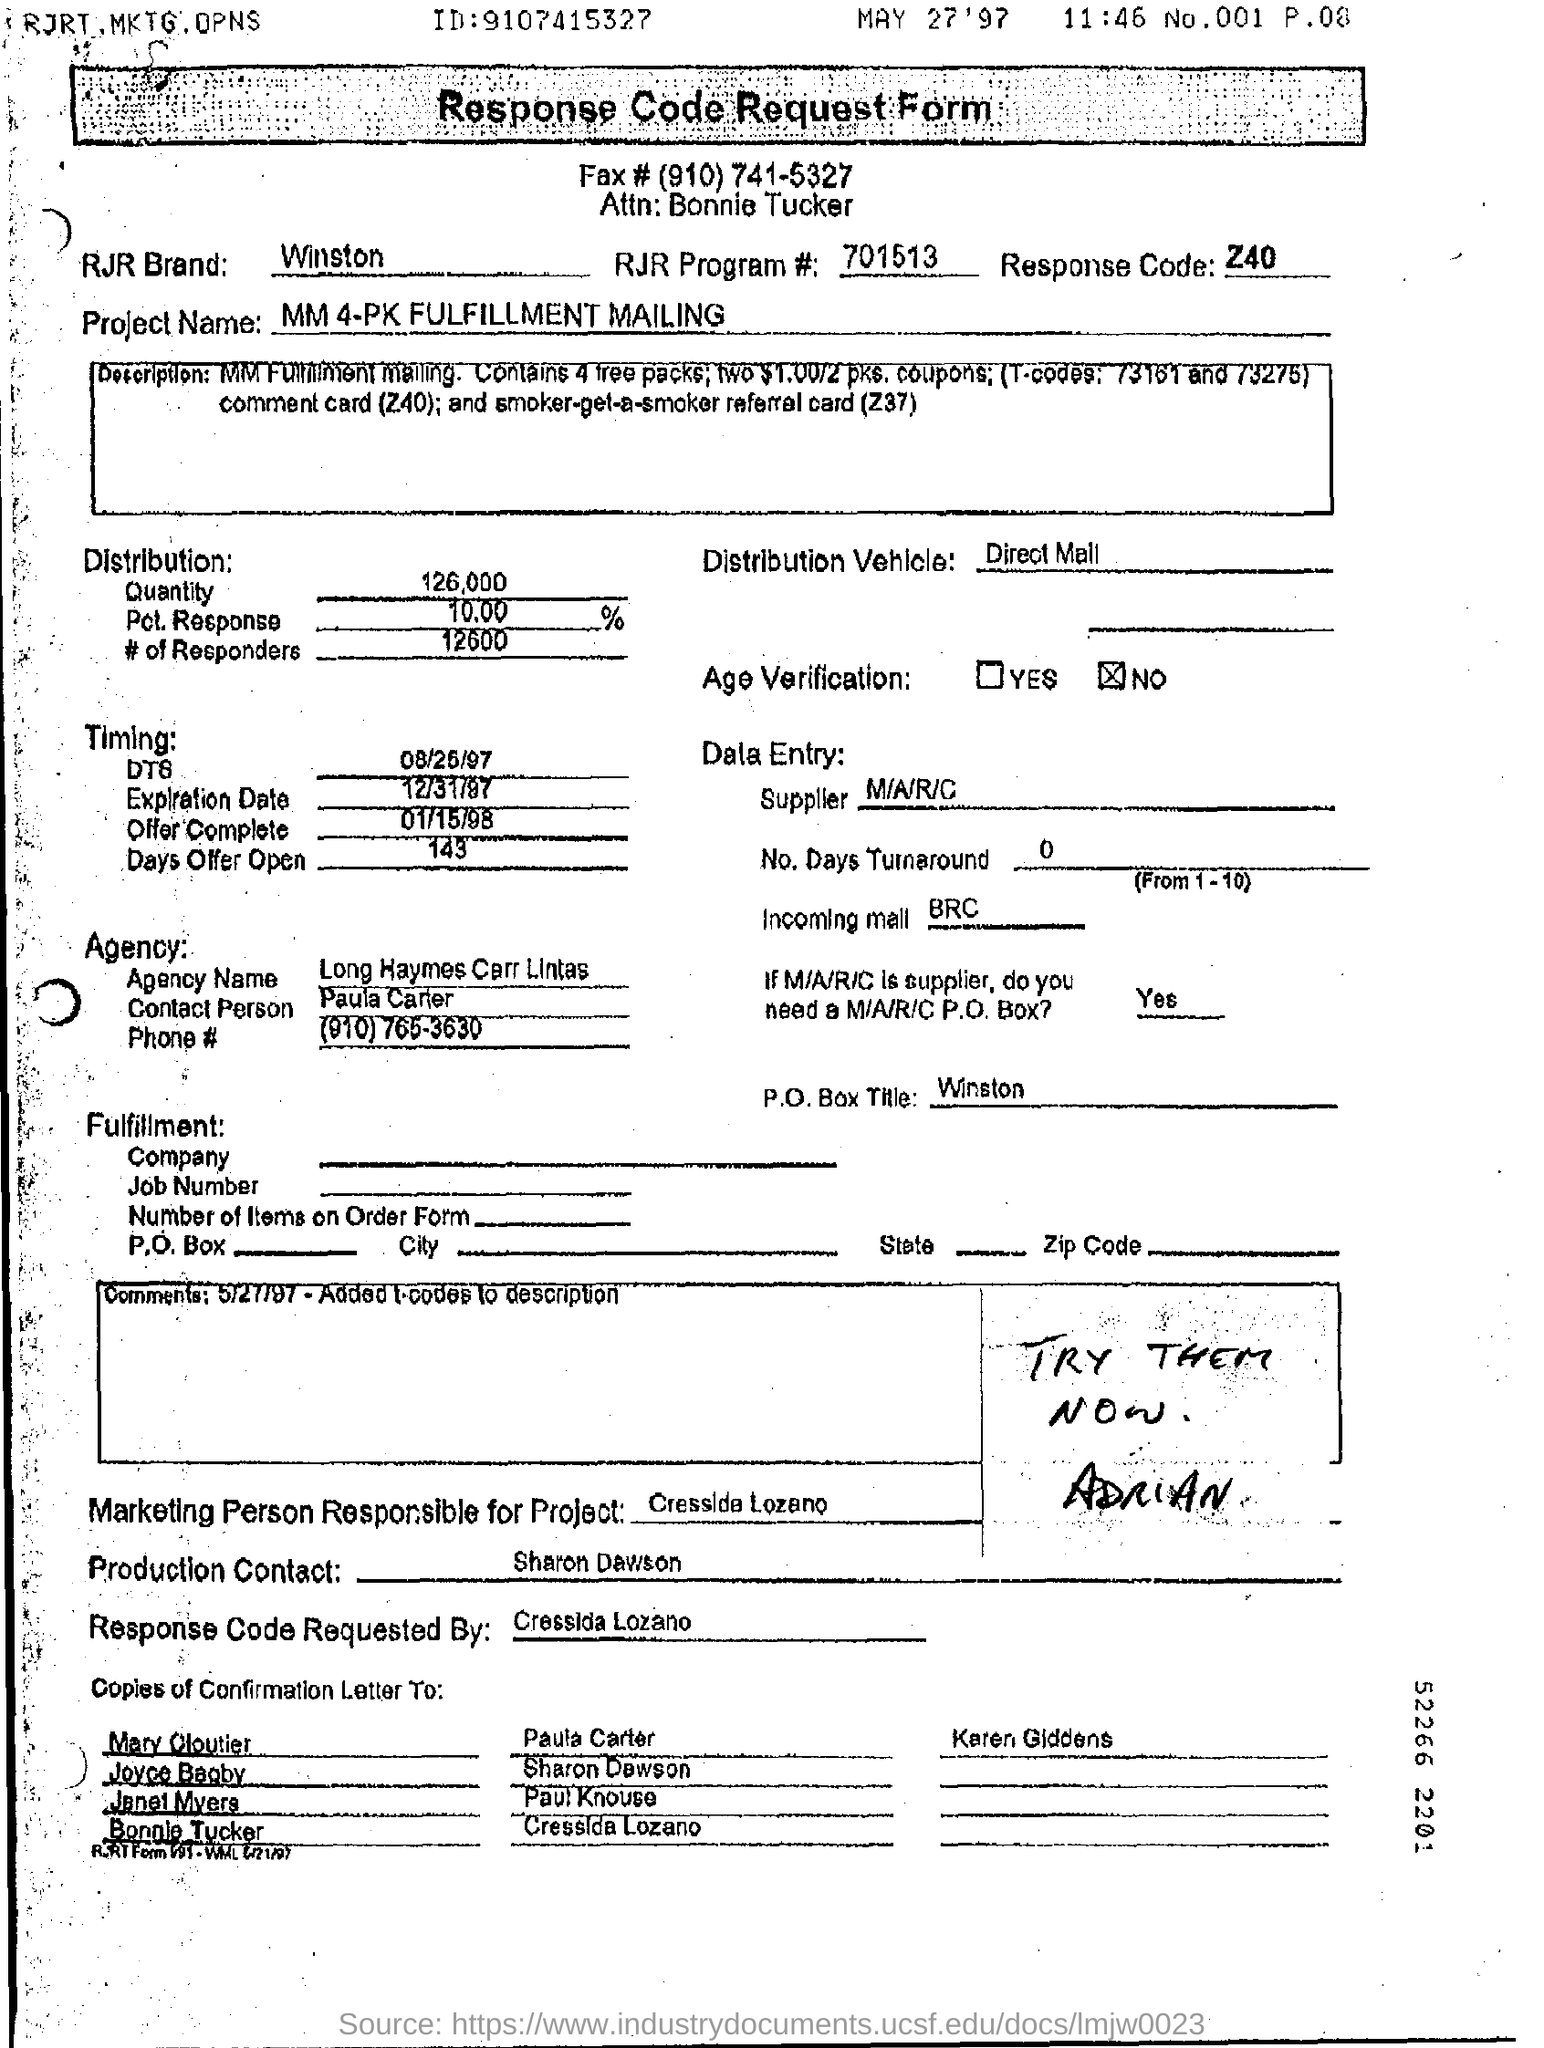Give some essential details in this illustration. Long Haymes Carr Lintas is the name of the agency. The distribution vehicle is the means by which a direct mail campaign is delivered to its intended audience. This can include mailings sent via the Postal Service or other delivery services, as well as online campaigns and other forms of digital marketing. The goal of the distribution vehicle is to effectively reach the target audience and deliver the message contained in the campaign in a way that is compelling and engaging. 